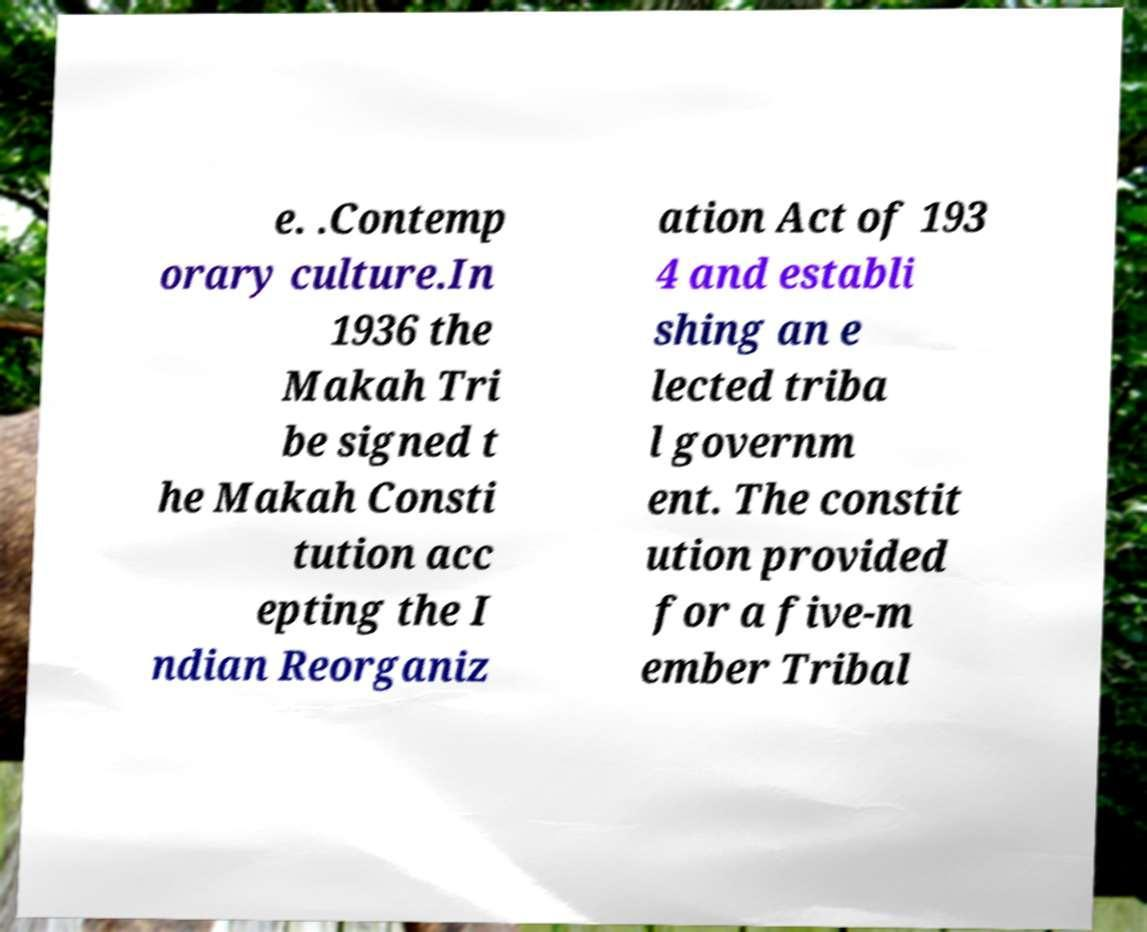For documentation purposes, I need the text within this image transcribed. Could you provide that? e. .Contemp orary culture.In 1936 the Makah Tri be signed t he Makah Consti tution acc epting the I ndian Reorganiz ation Act of 193 4 and establi shing an e lected triba l governm ent. The constit ution provided for a five-m ember Tribal 